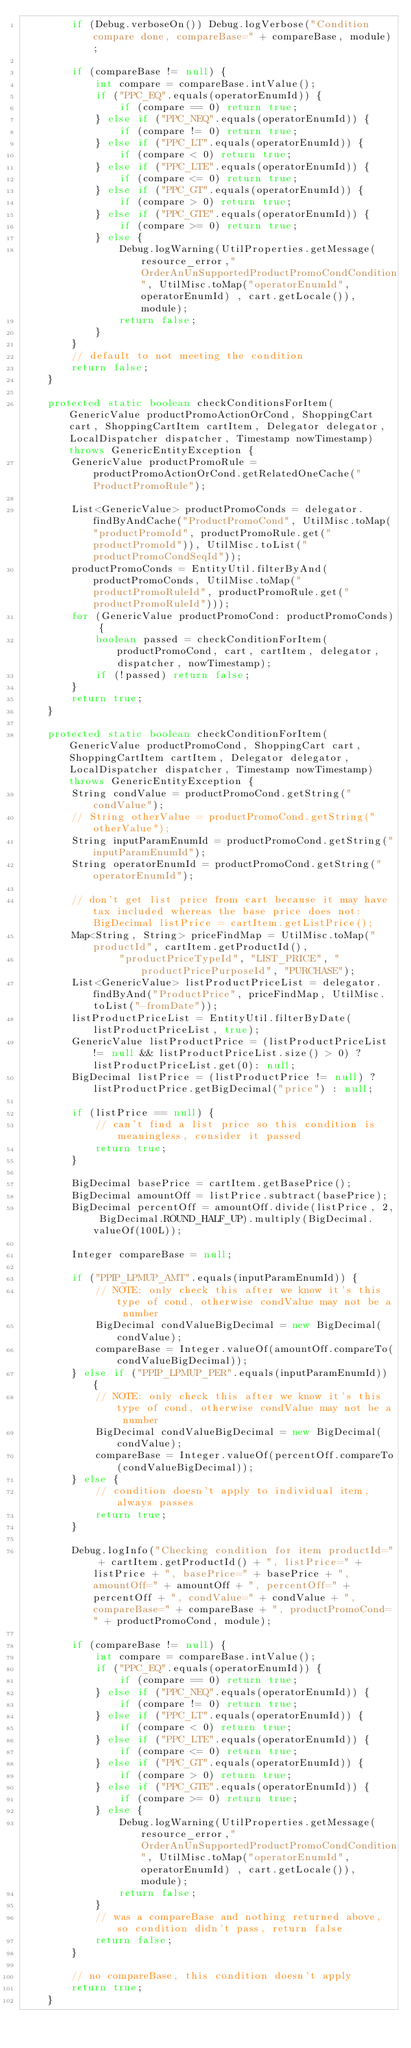Convert code to text. <code><loc_0><loc_0><loc_500><loc_500><_Java_>        if (Debug.verboseOn()) Debug.logVerbose("Condition compare done, compareBase=" + compareBase, module);

        if (compareBase != null) {
            int compare = compareBase.intValue();
            if ("PPC_EQ".equals(operatorEnumId)) {
                if (compare == 0) return true;
            } else if ("PPC_NEQ".equals(operatorEnumId)) {
                if (compare != 0) return true;
            } else if ("PPC_LT".equals(operatorEnumId)) {
                if (compare < 0) return true;
            } else if ("PPC_LTE".equals(operatorEnumId)) {
                if (compare <= 0) return true;
            } else if ("PPC_GT".equals(operatorEnumId)) {
                if (compare > 0) return true;
            } else if ("PPC_GTE".equals(operatorEnumId)) {
                if (compare >= 0) return true;
            } else {
                Debug.logWarning(UtilProperties.getMessage(resource_error,"OrderAnUnSupportedProductPromoCondCondition", UtilMisc.toMap("operatorEnumId",operatorEnumId) , cart.getLocale()), module);
                return false;
            }
        }
        // default to not meeting the condition
        return false;
    }

    protected static boolean checkConditionsForItem(GenericValue productPromoActionOrCond, ShoppingCart cart, ShoppingCartItem cartItem, Delegator delegator, LocalDispatcher dispatcher, Timestamp nowTimestamp) throws GenericEntityException {
        GenericValue productPromoRule = productPromoActionOrCond.getRelatedOneCache("ProductPromoRule");

        List<GenericValue> productPromoConds = delegator.findByAndCache("ProductPromoCond", UtilMisc.toMap("productPromoId", productPromoRule.get("productPromoId")), UtilMisc.toList("productPromoCondSeqId"));
        productPromoConds = EntityUtil.filterByAnd(productPromoConds, UtilMisc.toMap("productPromoRuleId", productPromoRule.get("productPromoRuleId")));
        for (GenericValue productPromoCond: productPromoConds) {
            boolean passed = checkConditionForItem(productPromoCond, cart, cartItem, delegator, dispatcher, nowTimestamp);
            if (!passed) return false;
        }
        return true;
    }

    protected static boolean checkConditionForItem(GenericValue productPromoCond, ShoppingCart cart, ShoppingCartItem cartItem, Delegator delegator, LocalDispatcher dispatcher, Timestamp nowTimestamp) throws GenericEntityException {
        String condValue = productPromoCond.getString("condValue");
        // String otherValue = productPromoCond.getString("otherValue");
        String inputParamEnumId = productPromoCond.getString("inputParamEnumId");
        String operatorEnumId = productPromoCond.getString("operatorEnumId");

        // don't get list price from cart because it may have tax included whereas the base price does not: BigDecimal listPrice = cartItem.getListPrice();
        Map<String, String> priceFindMap = UtilMisc.toMap("productId", cartItem.getProductId(),
                "productPriceTypeId", "LIST_PRICE", "productPricePurposeId", "PURCHASE");
        List<GenericValue> listProductPriceList = delegator.findByAnd("ProductPrice", priceFindMap, UtilMisc.toList("-fromDate"));
        listProductPriceList = EntityUtil.filterByDate(listProductPriceList, true);
        GenericValue listProductPrice = (listProductPriceList != null && listProductPriceList.size() > 0) ? listProductPriceList.get(0): null;
        BigDecimal listPrice = (listProductPrice != null) ? listProductPrice.getBigDecimal("price") : null;

        if (listPrice == null) {
            // can't find a list price so this condition is meaningless, consider it passed
            return true;
        }

        BigDecimal basePrice = cartItem.getBasePrice();
        BigDecimal amountOff = listPrice.subtract(basePrice);
        BigDecimal percentOff = amountOff.divide(listPrice, 2, BigDecimal.ROUND_HALF_UP).multiply(BigDecimal.valueOf(100L));

        Integer compareBase = null;

        if ("PPIP_LPMUP_AMT".equals(inputParamEnumId)) {
            // NOTE: only check this after we know it's this type of cond, otherwise condValue may not be a number
            BigDecimal condValueBigDecimal = new BigDecimal(condValue);
            compareBase = Integer.valueOf(amountOff.compareTo(condValueBigDecimal));
        } else if ("PPIP_LPMUP_PER".equals(inputParamEnumId)) {
            // NOTE: only check this after we know it's this type of cond, otherwise condValue may not be a number
            BigDecimal condValueBigDecimal = new BigDecimal(condValue);
            compareBase = Integer.valueOf(percentOff.compareTo(condValueBigDecimal));
        } else {
            // condition doesn't apply to individual item, always passes
            return true;
        }

        Debug.logInfo("Checking condition for item productId=" + cartItem.getProductId() + ", listPrice=" + listPrice + ", basePrice=" + basePrice + ", amountOff=" + amountOff + ", percentOff=" + percentOff + ", condValue=" + condValue + ", compareBase=" + compareBase + ", productPromoCond=" + productPromoCond, module);

        if (compareBase != null) {
            int compare = compareBase.intValue();
            if ("PPC_EQ".equals(operatorEnumId)) {
                if (compare == 0) return true;
            } else if ("PPC_NEQ".equals(operatorEnumId)) {
                if (compare != 0) return true;
            } else if ("PPC_LT".equals(operatorEnumId)) {
                if (compare < 0) return true;
            } else if ("PPC_LTE".equals(operatorEnumId)) {
                if (compare <= 0) return true;
            } else if ("PPC_GT".equals(operatorEnumId)) {
                if (compare > 0) return true;
            } else if ("PPC_GTE".equals(operatorEnumId)) {
                if (compare >= 0) return true;
            } else {
                Debug.logWarning(UtilProperties.getMessage(resource_error,"OrderAnUnSupportedProductPromoCondCondition", UtilMisc.toMap("operatorEnumId",operatorEnumId) , cart.getLocale()), module);
                return false;
            }
            // was a compareBase and nothing returned above, so condition didn't pass, return false
            return false;
        }

        // no compareBase, this condition doesn't apply
        return true;
    }
</code> 